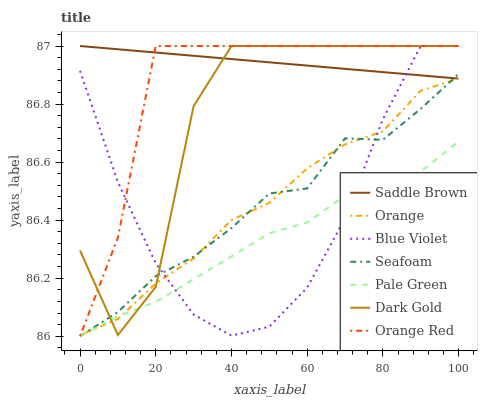Does Seafoam have the minimum area under the curve?
Answer yes or no. No. Does Seafoam have the maximum area under the curve?
Answer yes or no. No. Is Seafoam the smoothest?
Answer yes or no. No. Is Seafoam the roughest?
Answer yes or no. No. Does Orange Red have the lowest value?
Answer yes or no. No. Does Seafoam have the highest value?
Answer yes or no. No. Is Seafoam less than Orange Red?
Answer yes or no. Yes. Is Saddle Brown greater than Pale Green?
Answer yes or no. Yes. Does Seafoam intersect Orange Red?
Answer yes or no. No. 